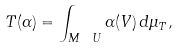<formula> <loc_0><loc_0><loc_500><loc_500>T ( \alpha ) = \int _ { M \ U } \alpha ( V ) \, d \mu _ { T } ,</formula> 